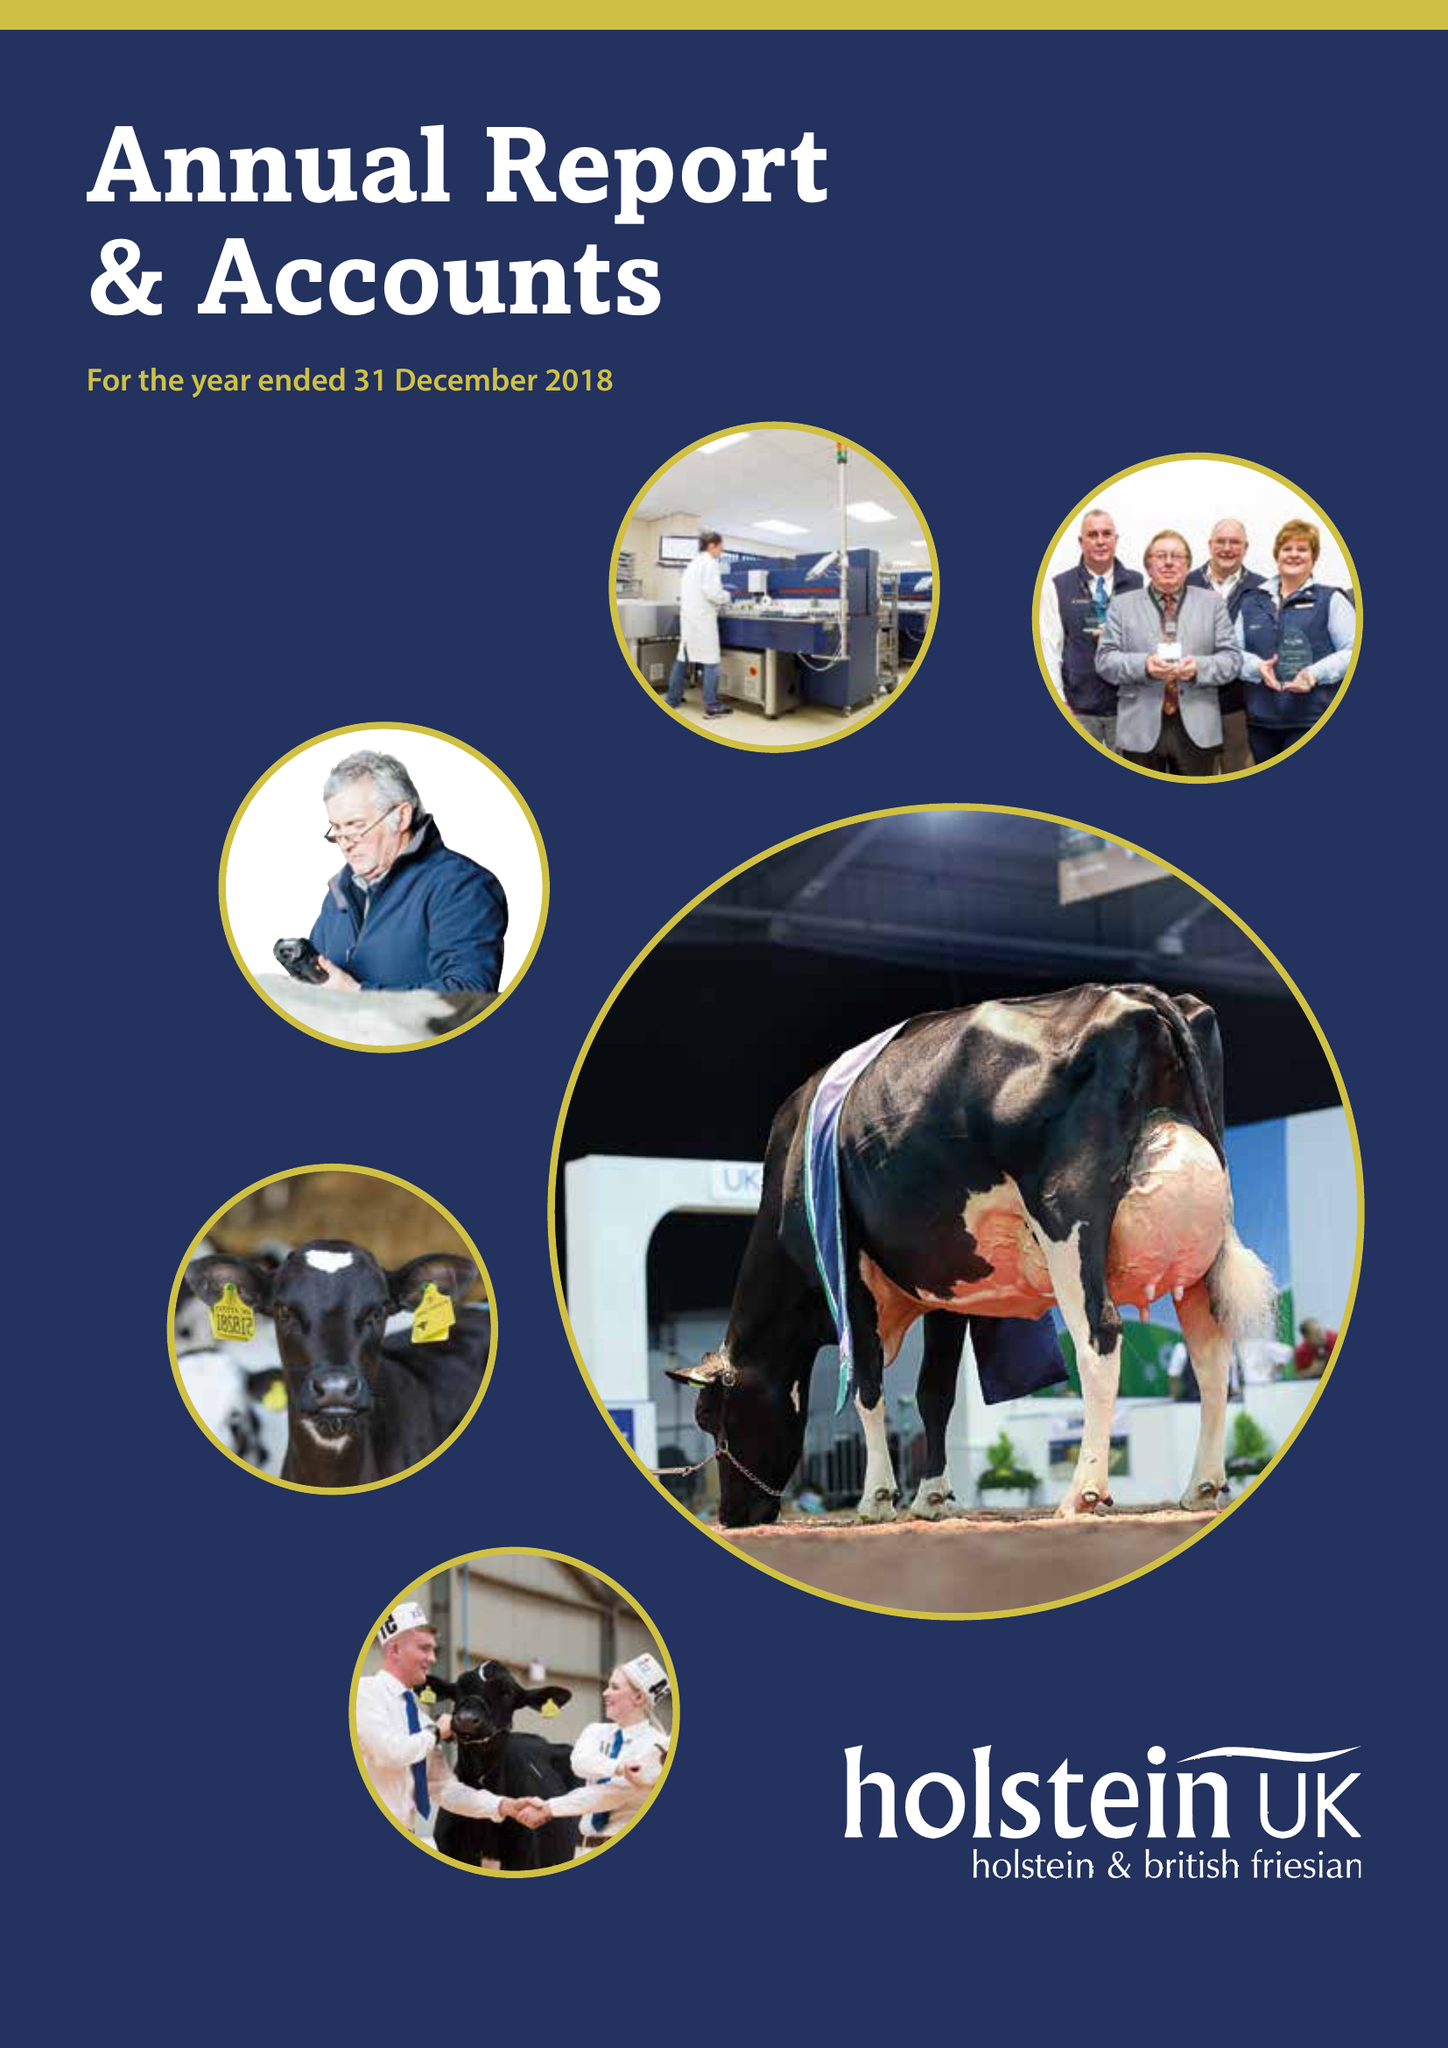What is the value for the report_date?
Answer the question using a single word or phrase. 2018-12-31 